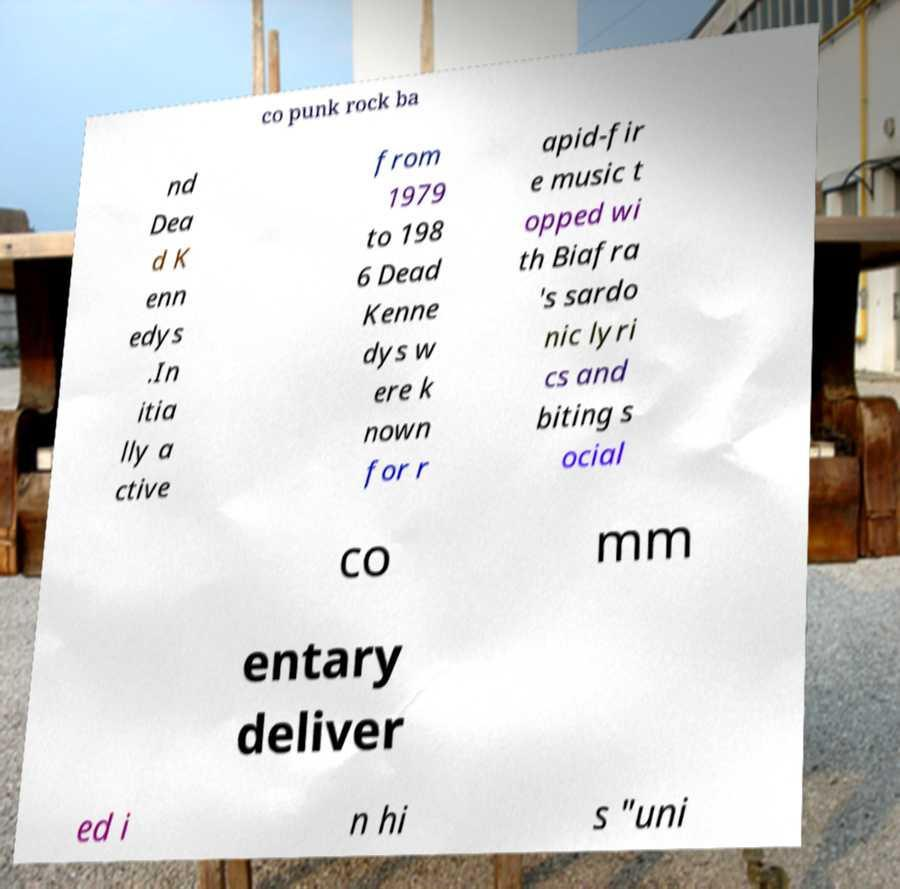Can you accurately transcribe the text from the provided image for me? co punk rock ba nd Dea d K enn edys .In itia lly a ctive from 1979 to 198 6 Dead Kenne dys w ere k nown for r apid-fir e music t opped wi th Biafra 's sardo nic lyri cs and biting s ocial co mm entary deliver ed i n hi s "uni 